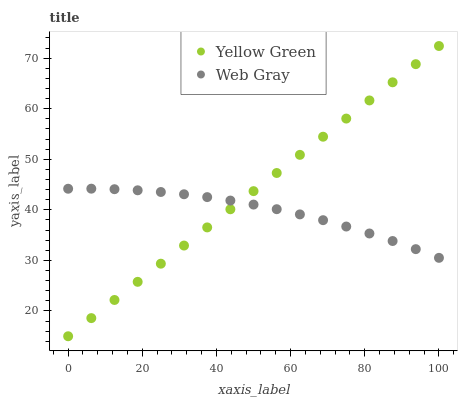Does Web Gray have the minimum area under the curve?
Answer yes or no. Yes. Does Yellow Green have the maximum area under the curve?
Answer yes or no. Yes. Does Yellow Green have the minimum area under the curve?
Answer yes or no. No. Is Yellow Green the smoothest?
Answer yes or no. Yes. Is Web Gray the roughest?
Answer yes or no. Yes. Is Yellow Green the roughest?
Answer yes or no. No. Does Yellow Green have the lowest value?
Answer yes or no. Yes. Does Yellow Green have the highest value?
Answer yes or no. Yes. Does Yellow Green intersect Web Gray?
Answer yes or no. Yes. Is Yellow Green less than Web Gray?
Answer yes or no. No. Is Yellow Green greater than Web Gray?
Answer yes or no. No. 